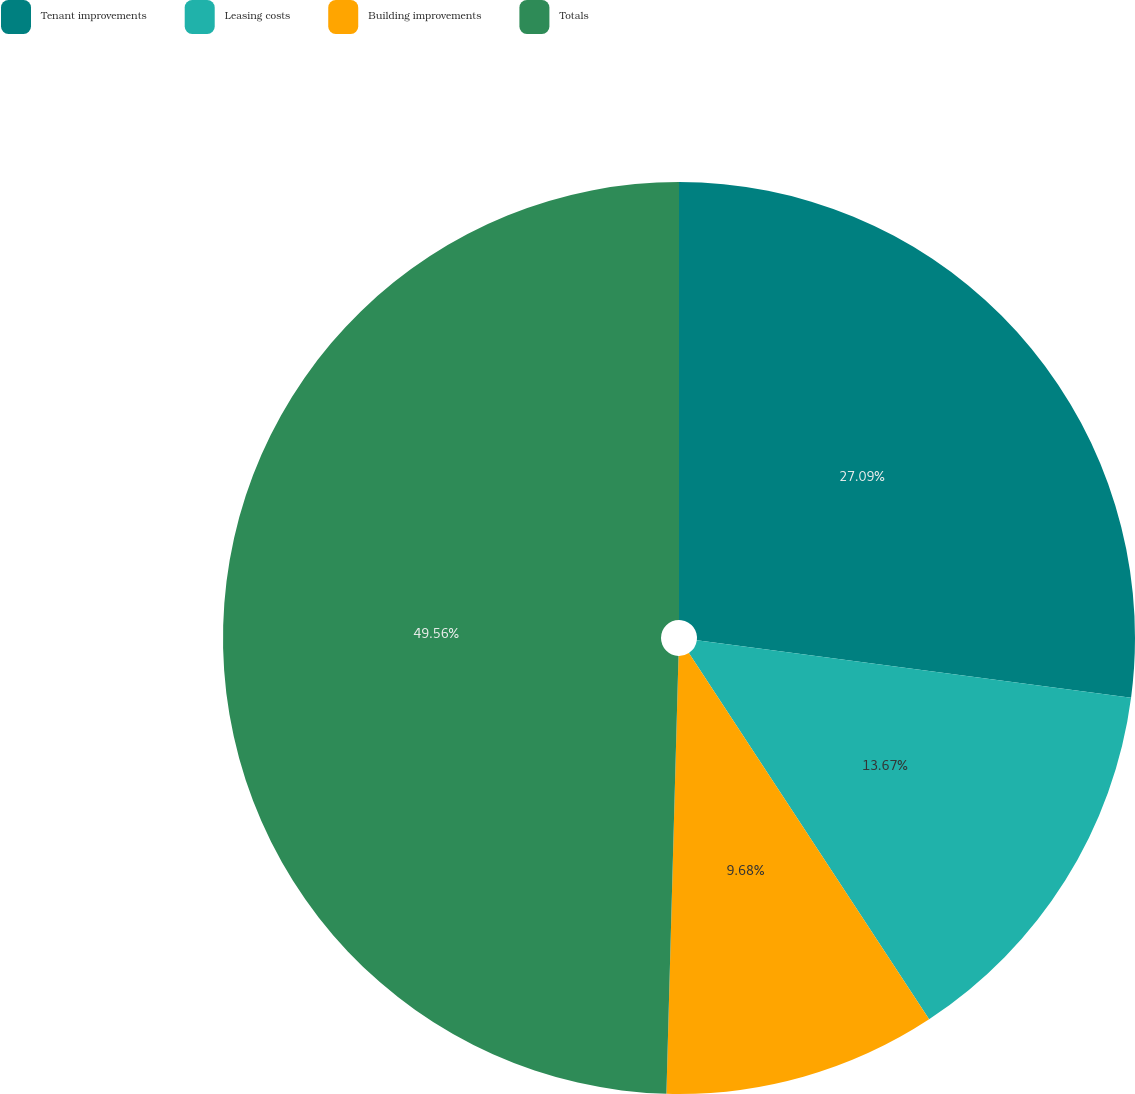Convert chart to OTSL. <chart><loc_0><loc_0><loc_500><loc_500><pie_chart><fcel>Tenant improvements<fcel>Leasing costs<fcel>Building improvements<fcel>Totals<nl><fcel>27.09%<fcel>13.67%<fcel>9.68%<fcel>49.56%<nl></chart> 